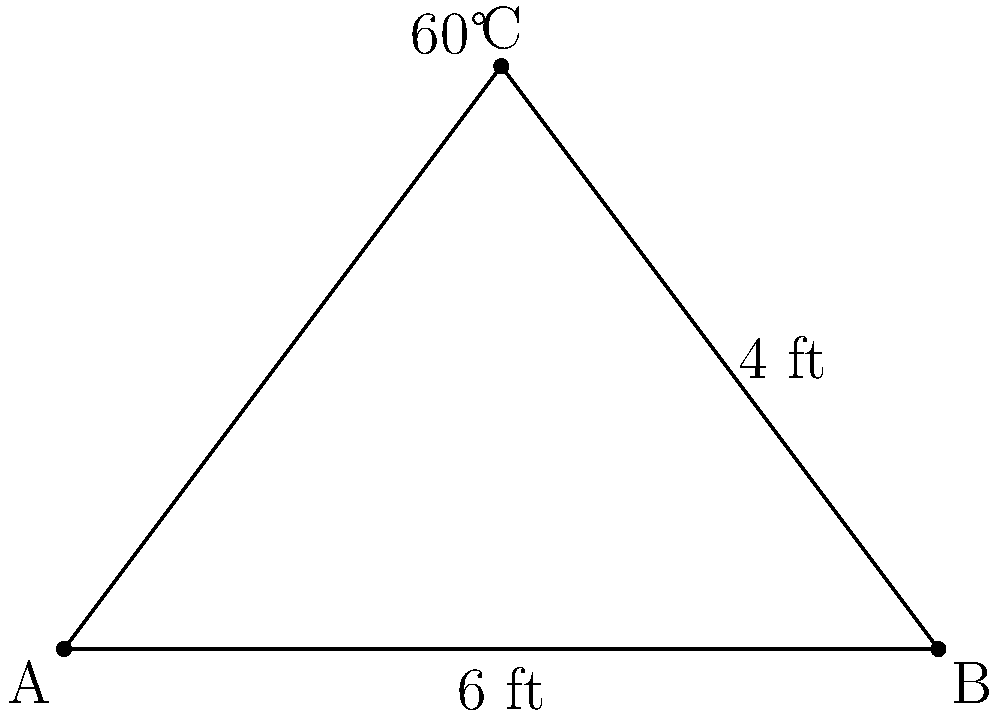During a home renovation, two support beams need to intersect at a 60° angle to provide proper structural support. If one beam is 6 feet long and the perpendicular distance from its endpoint to the other beam is 4 feet, what is the length of the second beam from the intersection point to its endpoint? Let's approach this step-by-step:

1) The given information forms a right-angled triangle. We can use trigonometry to solve this.

2) In the triangle:
   - The hypotenuse is the second beam we're trying to find.
   - We know one side is 4 feet (the perpendicular distance).
   - The angle between the hypotenuse and the 6-foot beam is 60°.

3) In a 30-60-90 triangle, the ratio of sides is 1 : √3 : 2.

4) The side opposite to the 60° angle (which is 4 feet) corresponds to the √3 part of the ratio.

5) If 4 feet corresponds to √3, then the hypotenuse (which corresponds to 2 in the ratio) would be:

   $$(4 * 2) / \sqrt{3} = 8 / \sqrt{3}$$

6) To simplify:
   $$8 / \sqrt{3} = 8 * \sqrt{3} / 3 = 8\sqrt{3} / 3 \approx 4.62$$

Therefore, the length of the second beam from the intersection point to its endpoint is $8\sqrt{3} / 3$ feet or approximately 4.62 feet.
Answer: $8\sqrt{3} / 3$ feet 